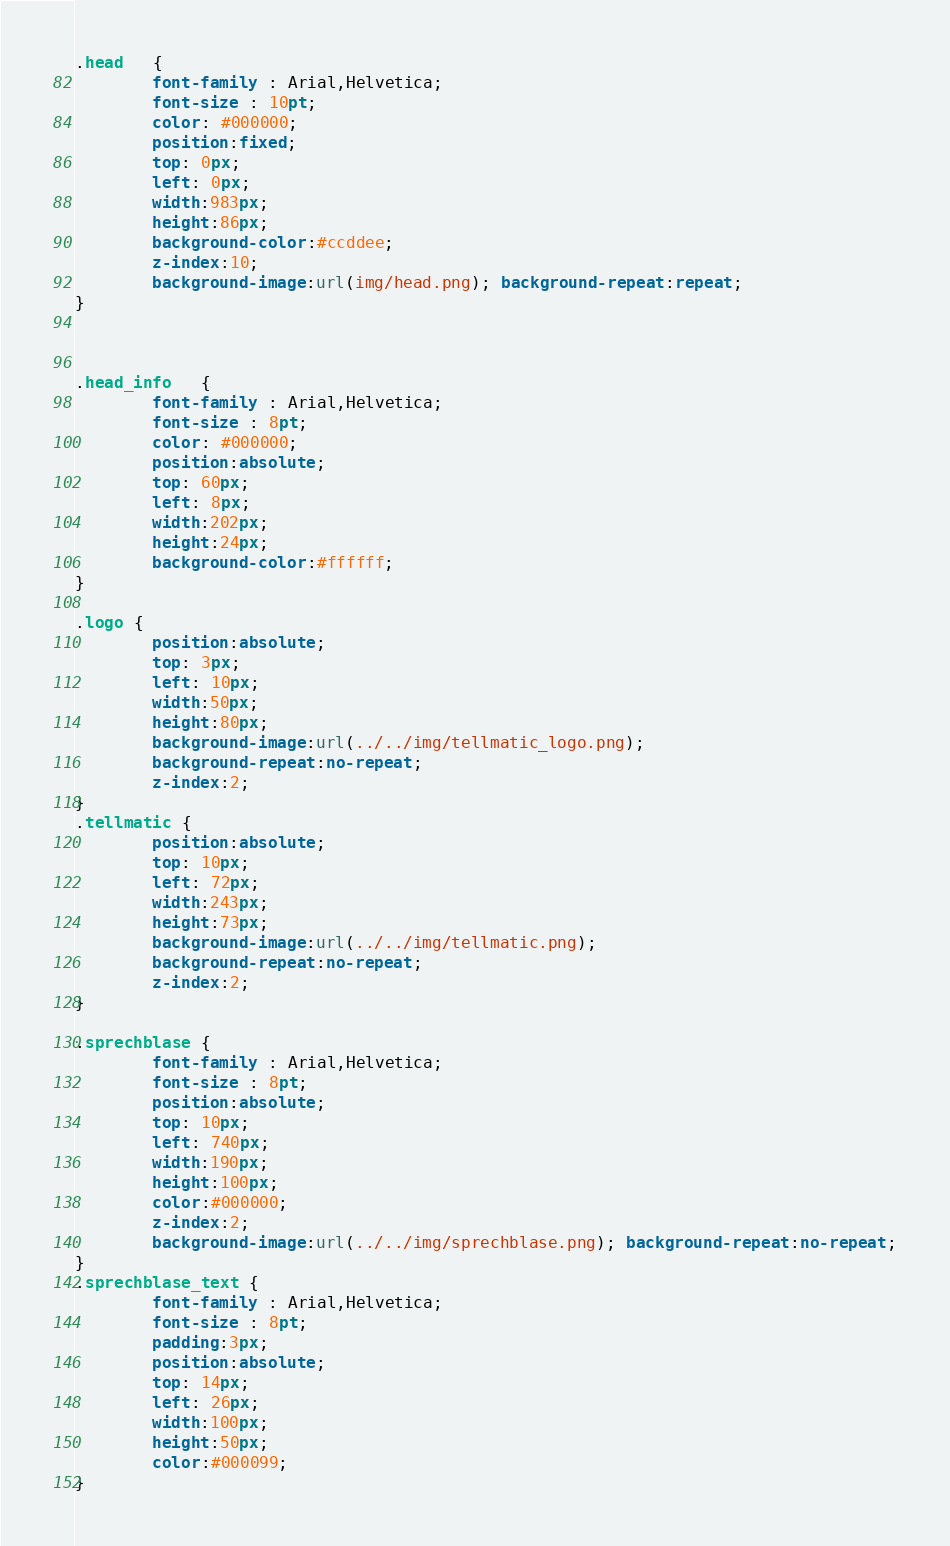<code> <loc_0><loc_0><loc_500><loc_500><_CSS_>.head   {
		font-family : Arial,Helvetica; 
		font-size : 10pt;
		color: #000000;
		position:fixed;
		top: 0px;
		left: 0px;
		width:983px; 
		height:86px;
		background-color:#ccddee;
		z-index:10;
		background-image:url(img/head.png); background-repeat:repeat;
}



.head_info   {
		font-family : Arial,Helvetica; 
		font-size : 8pt;
		color: #000000;
		position:absolute;
		top: 60px;
		left: 8px;
		width:202px; 
		height:24px;
		background-color:#ffffff;
}

.logo {
		position:absolute;
		top: 3px;
		left: 10px;
		width:50px; 
		height:80px;
		background-image:url(../../img/tellmatic_logo.png); 
		background-repeat:no-repeat;
		z-index:2;
}
.tellmatic {
		position:absolute;
		top: 10px;
		left: 72px;
		width:243px; 
		height:73px;
		background-image:url(../../img/tellmatic.png); 
		background-repeat:no-repeat;
		z-index:2;
}

.sprechblase {
		font-family : Arial,Helvetica; 
		font-size : 8pt;
		position:absolute;
		top: 10px;
		left: 740px;
		width:190px; 
		height:100px; 
		color:#000000;
		z-index:2;
		background-image:url(../../img/sprechblase.png); background-repeat:no-repeat;
}
.sprechblase_text {
		font-family : Arial,Helvetica; 
		font-size : 8pt;
		padding:3px;
		position:absolute;
		top: 14px;
		left: 26px;
		width:100px; 
		height:50px; 
		color:#000099;
}
</code> 